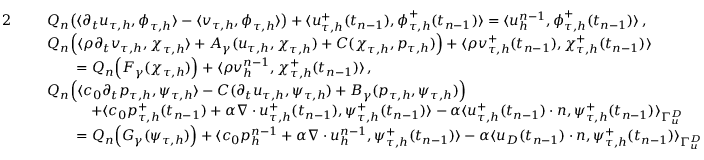<formula> <loc_0><loc_0><loc_500><loc_500>\begin{array} { r l } { 2 } & { \begin{array} { r l } & { Q _ { n } \left ( \langle \partial _ { t } \boldsymbol u _ { \tau , h } , \boldsymbol \phi _ { \tau , h } \rangle - \langle \boldsymbol v _ { \tau , h } , \boldsymbol \phi _ { \tau , h } \rangle \right ) + \langle \boldsymbol u _ { \tau , h } ^ { + } ( t _ { n - 1 } ) , \boldsymbol \phi _ { \tau , h } ^ { + } ( t _ { n - 1 } ) \rangle = \langle \boldsymbol u _ { h } ^ { n - 1 } , \boldsymbol \phi _ { \tau , h } ^ { + } ( t _ { n - 1 } ) \rangle \, , } \end{array} } \\ & { \begin{array} { r l } & { Q _ { n } \left ( \langle \rho \partial _ { t } \boldsymbol v _ { \tau , h } , \boldsymbol \chi _ { \tau , h } \rangle + A _ { \gamma } ( \boldsymbol u _ { \tau , h } , \boldsymbol \chi _ { \tau , h } ) + C ( \boldsymbol \chi _ { \tau , h } , p _ { \tau , h } ) \right ) + \langle \rho \boldsymbol v _ { \tau , h } ^ { + } ( t _ { n - 1 } ) , \boldsymbol \chi _ { \tau , h } ^ { + } ( t _ { n - 1 } ) \rangle } \\ & { \quad = Q _ { n } \left ( F _ { \gamma } ( \boldsymbol \chi _ { \tau , h } ) \right ) + \langle \rho \boldsymbol v _ { h } ^ { n - 1 } , \boldsymbol \chi _ { \tau , h } ^ { + } ( t _ { n - 1 } ) \rangle \, , } \end{array} } \\ & { \begin{array} { r l } & { Q _ { n } \left ( \langle c _ { 0 } \partial _ { t } p _ { \tau , h } , \psi _ { \tau , h } \rangle - C ( \partial _ { t } \boldsymbol u _ { \tau , h } , \psi _ { \tau , h } ) + B _ { \gamma } ( p _ { \tau , h } , \psi _ { \tau , h } ) \right ) } \\ & { \quad + \langle c _ { 0 } p _ { \tau , h } ^ { + } ( t _ { n - 1 } ) + \alpha \nabla \cdot \boldsymbol u _ { \tau , h } ^ { + } ( t _ { n - 1 } ) , \psi _ { \tau , h } ^ { + } ( t _ { n - 1 } ) \rangle - \alpha \langle \boldsymbol u _ { \tau , h } ^ { + } ( t _ { n - 1 } ) \cdot \boldsymbol n , \psi _ { \tau , h } ^ { + } ( t _ { n - 1 } ) \rangle _ { \Gamma _ { \boldsymbol u } ^ { D } } } \\ & { \quad = Q _ { n } \left ( G _ { \gamma } ( \psi _ { \tau , h } ) \right ) + \langle c _ { 0 } p _ { h } ^ { n - 1 } + \alpha \nabla \cdot \boldsymbol u _ { h } ^ { n - 1 } , \psi _ { \tau , h } ^ { + } ( t _ { n - 1 } ) \rangle - \alpha \langle \boldsymbol u _ { D } ( t _ { n - 1 } ) \cdot \boldsymbol n , \psi _ { \tau , h } ^ { + } ( t _ { n - 1 } ) \rangle _ { \Gamma _ { \boldsymbol u } ^ { D } } } \end{array} } \end{array}</formula> 